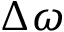Convert formula to latex. <formula><loc_0><loc_0><loc_500><loc_500>\Delta \omega</formula> 